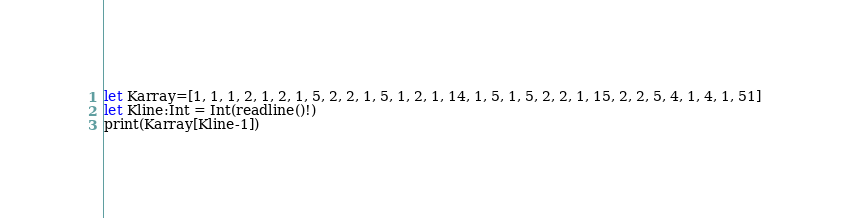Convert code to text. <code><loc_0><loc_0><loc_500><loc_500><_Swift_>let Karray=[1, 1, 1, 2, 1, 2, 1, 5, 2, 2, 1, 5, 1, 2, 1, 14, 1, 5, 1, 5, 2, 2, 1, 15, 2, 2, 5, 4, 1, 4, 1, 51]
let Kline:Int = Int(readline()!)
print(Karray[Kline-1])</code> 